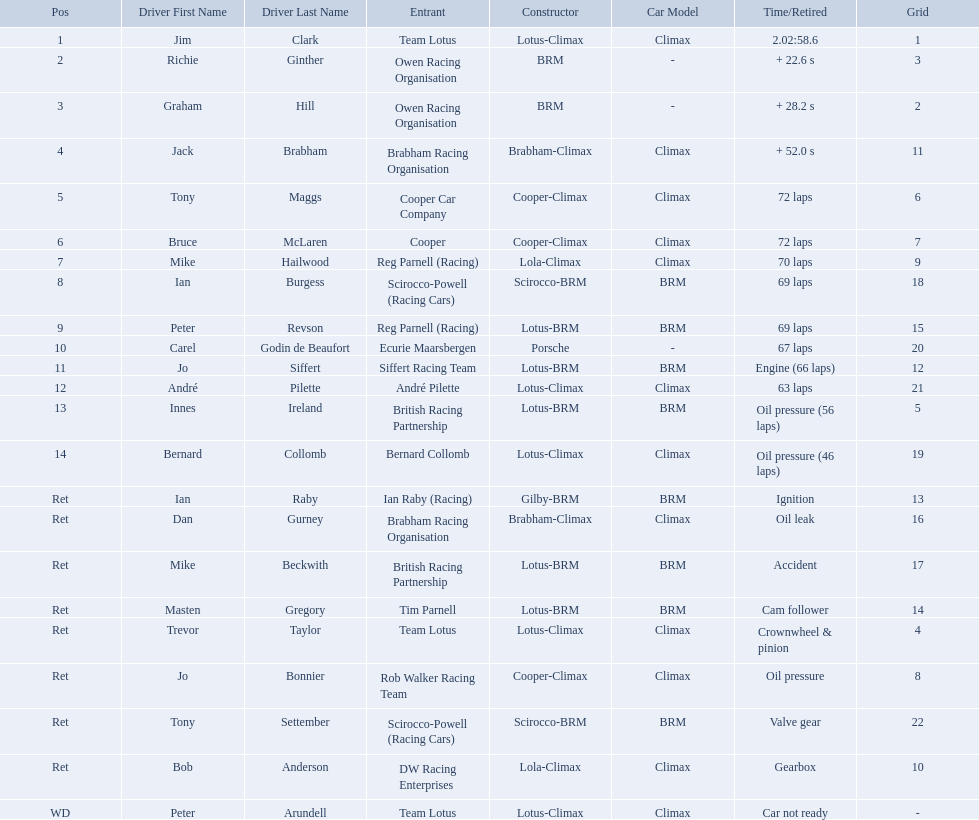Who are all the drivers? Jim Clark, Richie Ginther, Graham Hill, Jack Brabham, Tony Maggs, Bruce McLaren, Mike Hailwood, Ian Burgess, Peter Revson, Carel Godin de Beaufort, Jo Siffert, André Pilette, Innes Ireland, Bernard Collomb, Ian Raby, Dan Gurney, Mike Beckwith, Masten Gregory, Trevor Taylor, Jo Bonnier, Tony Settember, Bob Anderson, Peter Arundell. What position were they in? 1, 2, 3, 4, 5, 6, 7, 8, 9, 10, 11, 12, 13, 14, Ret, Ret, Ret, Ret, Ret, Ret, Ret, Ret, WD. Help me parse the entirety of this table. {'header': ['Pos', 'Driver First Name', 'Driver Last Name', 'Entrant', 'Constructor', 'Car Model', 'Time/Retired', 'Grid'], 'rows': [['1', 'Jim', 'Clark', 'Team Lotus', 'Lotus-Climax', 'Climax', '2.02:58.6', '1'], ['2', 'Richie', 'Ginther', 'Owen Racing Organisation', 'BRM', '-', '+ 22.6 s', '3'], ['3', 'Graham', 'Hill', 'Owen Racing Organisation', 'BRM', '-', '+ 28.2 s', '2'], ['4', 'Jack', 'Brabham', 'Brabham Racing Organisation', 'Brabham-Climax', 'Climax', '+ 52.0 s', '11'], ['5', 'Tony', 'Maggs', 'Cooper Car Company', 'Cooper-Climax', 'Climax', '72 laps', '6'], ['6', 'Bruce', 'McLaren', 'Cooper', 'Cooper-Climax', 'Climax', '72 laps', '7'], ['7', 'Mike', 'Hailwood', 'Reg Parnell (Racing)', 'Lola-Climax', 'Climax', '70 laps', '9'], ['8', 'Ian', 'Burgess', 'Scirocco-Powell (Racing Cars)', 'Scirocco-BRM', 'BRM', '69 laps', '18'], ['9', 'Peter', 'Revson', 'Reg Parnell (Racing)', 'Lotus-BRM', 'BRM', '69 laps', '15'], ['10', 'Carel', 'Godin de Beaufort', 'Ecurie Maarsbergen', 'Porsche', '-', '67 laps', '20'], ['11', 'Jo', 'Siffert', 'Siffert Racing Team', 'Lotus-BRM', 'BRM', 'Engine (66 laps)', '12'], ['12', 'André', 'Pilette', 'André Pilette', 'Lotus-Climax', 'Climax', '63 laps', '21'], ['13', 'Innes', 'Ireland', 'British Racing Partnership', 'Lotus-BRM', 'BRM', 'Oil pressure (56 laps)', '5'], ['14', 'Bernard', 'Collomb', 'Bernard Collomb', 'Lotus-Climax', 'Climax', 'Oil pressure (46 laps)', '19'], ['Ret', 'Ian', 'Raby', 'Ian Raby (Racing)', 'Gilby-BRM', 'BRM', 'Ignition', '13'], ['Ret', 'Dan', 'Gurney', 'Brabham Racing Organisation', 'Brabham-Climax', 'Climax', 'Oil leak', '16'], ['Ret', 'Mike', 'Beckwith', 'British Racing Partnership', 'Lotus-BRM', 'BRM', 'Accident', '17'], ['Ret', 'Masten', 'Gregory', 'Tim Parnell', 'Lotus-BRM', 'BRM', 'Cam follower', '14'], ['Ret', 'Trevor', 'Taylor', 'Team Lotus', 'Lotus-Climax', 'Climax', 'Crownwheel & pinion', '4'], ['Ret', 'Jo', 'Bonnier', 'Rob Walker Racing Team', 'Cooper-Climax', 'Climax', 'Oil pressure', '8'], ['Ret', 'Tony', 'Settember', 'Scirocco-Powell (Racing Cars)', 'Scirocco-BRM', 'BRM', 'Valve gear', '22'], ['Ret', 'Bob', 'Anderson', 'DW Racing Enterprises', 'Lola-Climax', 'Climax', 'Gearbox', '10'], ['WD', 'Peter', 'Arundell', 'Team Lotus', 'Lotus-Climax', 'Climax', 'Car not ready', '-']]} What about just tony maggs and jo siffert? 5, 11. And between them, which driver came in earlier? Tony Maggs. Who were the drivers at the 1963 international gold cup? Jim Clark, Richie Ginther, Graham Hill, Jack Brabham, Tony Maggs, Bruce McLaren, Mike Hailwood, Ian Burgess, Peter Revson, Carel Godin de Beaufort, Jo Siffert, André Pilette, Innes Ireland, Bernard Collomb, Ian Raby, Dan Gurney, Mike Beckwith, Masten Gregory, Trevor Taylor, Jo Bonnier, Tony Settember, Bob Anderson, Peter Arundell. What was tony maggs position? 5. What was jo siffert? 11. Who came in earlier? Tony Maggs. What are the listed driver names? Jim Clark, Richie Ginther, Graham Hill, Jack Brabham, Tony Maggs, Bruce McLaren, Mike Hailwood, Ian Burgess, Peter Revson, Carel Godin de Beaufort, Jo Siffert, André Pilette, Innes Ireland, Bernard Collomb, Ian Raby, Dan Gurney, Mike Beckwith, Masten Gregory, Trevor Taylor, Jo Bonnier, Tony Settember, Bob Anderson, Peter Arundell. Which are tony maggs and jo siffert? Tony Maggs, Jo Siffert. What are their corresponding finishing places? 5, 11. Whose is better? Tony Maggs. Who were the drivers in the the 1963 international gold cup? Jim Clark, Richie Ginther, Graham Hill, Jack Brabham, Tony Maggs, Bruce McLaren, Mike Hailwood, Ian Burgess, Peter Revson, Carel Godin de Beaufort, Jo Siffert, André Pilette, Innes Ireland, Bernard Collomb, Ian Raby, Dan Gurney, Mike Beckwith, Masten Gregory, Trevor Taylor, Jo Bonnier, Tony Settember, Bob Anderson, Peter Arundell. Which drivers drove a cooper-climax car? Tony Maggs, Bruce McLaren, Jo Bonnier. What did these drivers place? 5, 6, Ret. What was the best placing position? 5. Who was the driver with this placing? Tony Maggs. Who all drive cars that were constructed bur climax? Jim Clark, Jack Brabham, Tony Maggs, Bruce McLaren, Mike Hailwood, André Pilette, Bernard Collomb, Dan Gurney, Trevor Taylor, Jo Bonnier, Bob Anderson, Peter Arundell. Which driver's climax constructed cars started in the top 10 on the grid? Jim Clark, Tony Maggs, Bruce McLaren, Mike Hailwood, Jo Bonnier, Bob Anderson. Of the top 10 starting climax constructed drivers, which ones did not finish the race? Jo Bonnier, Bob Anderson. Parse the full table. {'header': ['Pos', 'Driver First Name', 'Driver Last Name', 'Entrant', 'Constructor', 'Car Model', 'Time/Retired', 'Grid'], 'rows': [['1', 'Jim', 'Clark', 'Team Lotus', 'Lotus-Climax', 'Climax', '2.02:58.6', '1'], ['2', 'Richie', 'Ginther', 'Owen Racing Organisation', 'BRM', '-', '+ 22.6 s', '3'], ['3', 'Graham', 'Hill', 'Owen Racing Organisation', 'BRM', '-', '+ 28.2 s', '2'], ['4', 'Jack', 'Brabham', 'Brabham Racing Organisation', 'Brabham-Climax', 'Climax', '+ 52.0 s', '11'], ['5', 'Tony', 'Maggs', 'Cooper Car Company', 'Cooper-Climax', 'Climax', '72 laps', '6'], ['6', 'Bruce', 'McLaren', 'Cooper', 'Cooper-Climax', 'Climax', '72 laps', '7'], ['7', 'Mike', 'Hailwood', 'Reg Parnell (Racing)', 'Lola-Climax', 'Climax', '70 laps', '9'], ['8', 'Ian', 'Burgess', 'Scirocco-Powell (Racing Cars)', 'Scirocco-BRM', 'BRM', '69 laps', '18'], ['9', 'Peter', 'Revson', 'Reg Parnell (Racing)', 'Lotus-BRM', 'BRM', '69 laps', '15'], ['10', 'Carel', 'Godin de Beaufort', 'Ecurie Maarsbergen', 'Porsche', '-', '67 laps', '20'], ['11', 'Jo', 'Siffert', 'Siffert Racing Team', 'Lotus-BRM', 'BRM', 'Engine (66 laps)', '12'], ['12', 'André', 'Pilette', 'André Pilette', 'Lotus-Climax', 'Climax', '63 laps', '21'], ['13', 'Innes', 'Ireland', 'British Racing Partnership', 'Lotus-BRM', 'BRM', 'Oil pressure (56 laps)', '5'], ['14', 'Bernard', 'Collomb', 'Bernard Collomb', 'Lotus-Climax', 'Climax', 'Oil pressure (46 laps)', '19'], ['Ret', 'Ian', 'Raby', 'Ian Raby (Racing)', 'Gilby-BRM', 'BRM', 'Ignition', '13'], ['Ret', 'Dan', 'Gurney', 'Brabham Racing Organisation', 'Brabham-Climax', 'Climax', 'Oil leak', '16'], ['Ret', 'Mike', 'Beckwith', 'British Racing Partnership', 'Lotus-BRM', 'BRM', 'Accident', '17'], ['Ret', 'Masten', 'Gregory', 'Tim Parnell', 'Lotus-BRM', 'BRM', 'Cam follower', '14'], ['Ret', 'Trevor', 'Taylor', 'Team Lotus', 'Lotus-Climax', 'Climax', 'Crownwheel & pinion', '4'], ['Ret', 'Jo', 'Bonnier', 'Rob Walker Racing Team', 'Cooper-Climax', 'Climax', 'Oil pressure', '8'], ['Ret', 'Tony', 'Settember', 'Scirocco-Powell (Racing Cars)', 'Scirocco-BRM', 'BRM', 'Valve gear', '22'], ['Ret', 'Bob', 'Anderson', 'DW Racing Enterprises', 'Lola-Climax', 'Climax', 'Gearbox', '10'], ['WD', 'Peter', 'Arundell', 'Team Lotus', 'Lotus-Climax', 'Climax', 'Car not ready', '-']]} What was the failure that was engine related that took out the driver of the climax constructed car that did not finish even though it started in the top 10? Oil pressure. Who were the two that that a similar problem? Innes Ireland. What was their common problem? Oil pressure. Who drove in the 1963 international gold cup? Jim Clark, Richie Ginther, Graham Hill, Jack Brabham, Tony Maggs, Bruce McLaren, Mike Hailwood, Ian Burgess, Peter Revson, Carel Godin de Beaufort, Jo Siffert, André Pilette, Innes Ireland, Bernard Collomb, Ian Raby, Dan Gurney, Mike Beckwith, Masten Gregory, Trevor Taylor, Jo Bonnier, Tony Settember, Bob Anderson, Peter Arundell. Who had problems during the race? Jo Siffert, Innes Ireland, Bernard Collomb, Ian Raby, Dan Gurney, Mike Beckwith, Masten Gregory, Trevor Taylor, Jo Bonnier, Tony Settember, Bob Anderson, Peter Arundell. Of those who was still able to finish the race? Jo Siffert, Innes Ireland, Bernard Collomb. Of those who faced the same issue? Innes Ireland, Bernard Collomb. What issue did they have? Oil pressure. 